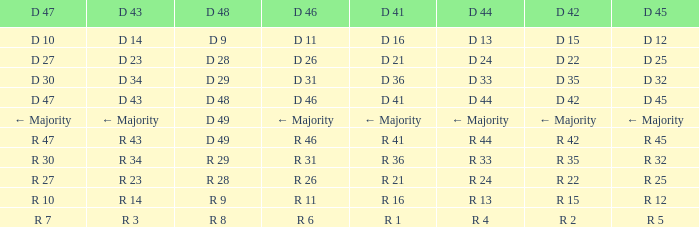Name the D 48 when it has a D 44 of d 33 D 29. 